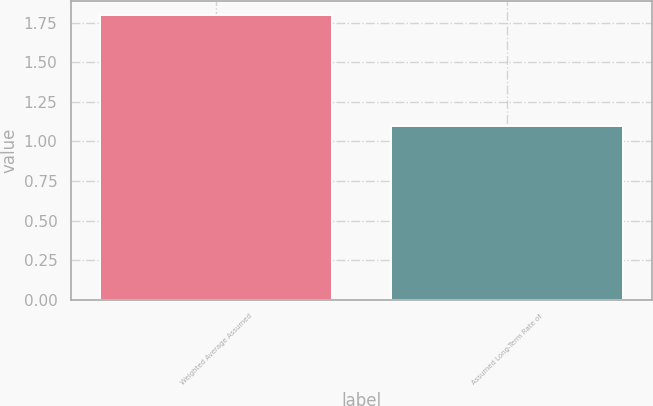Convert chart. <chart><loc_0><loc_0><loc_500><loc_500><bar_chart><fcel>Weighted Average Assumed<fcel>Assumed Long-Term Rate of<nl><fcel>1.8<fcel>1.1<nl></chart> 